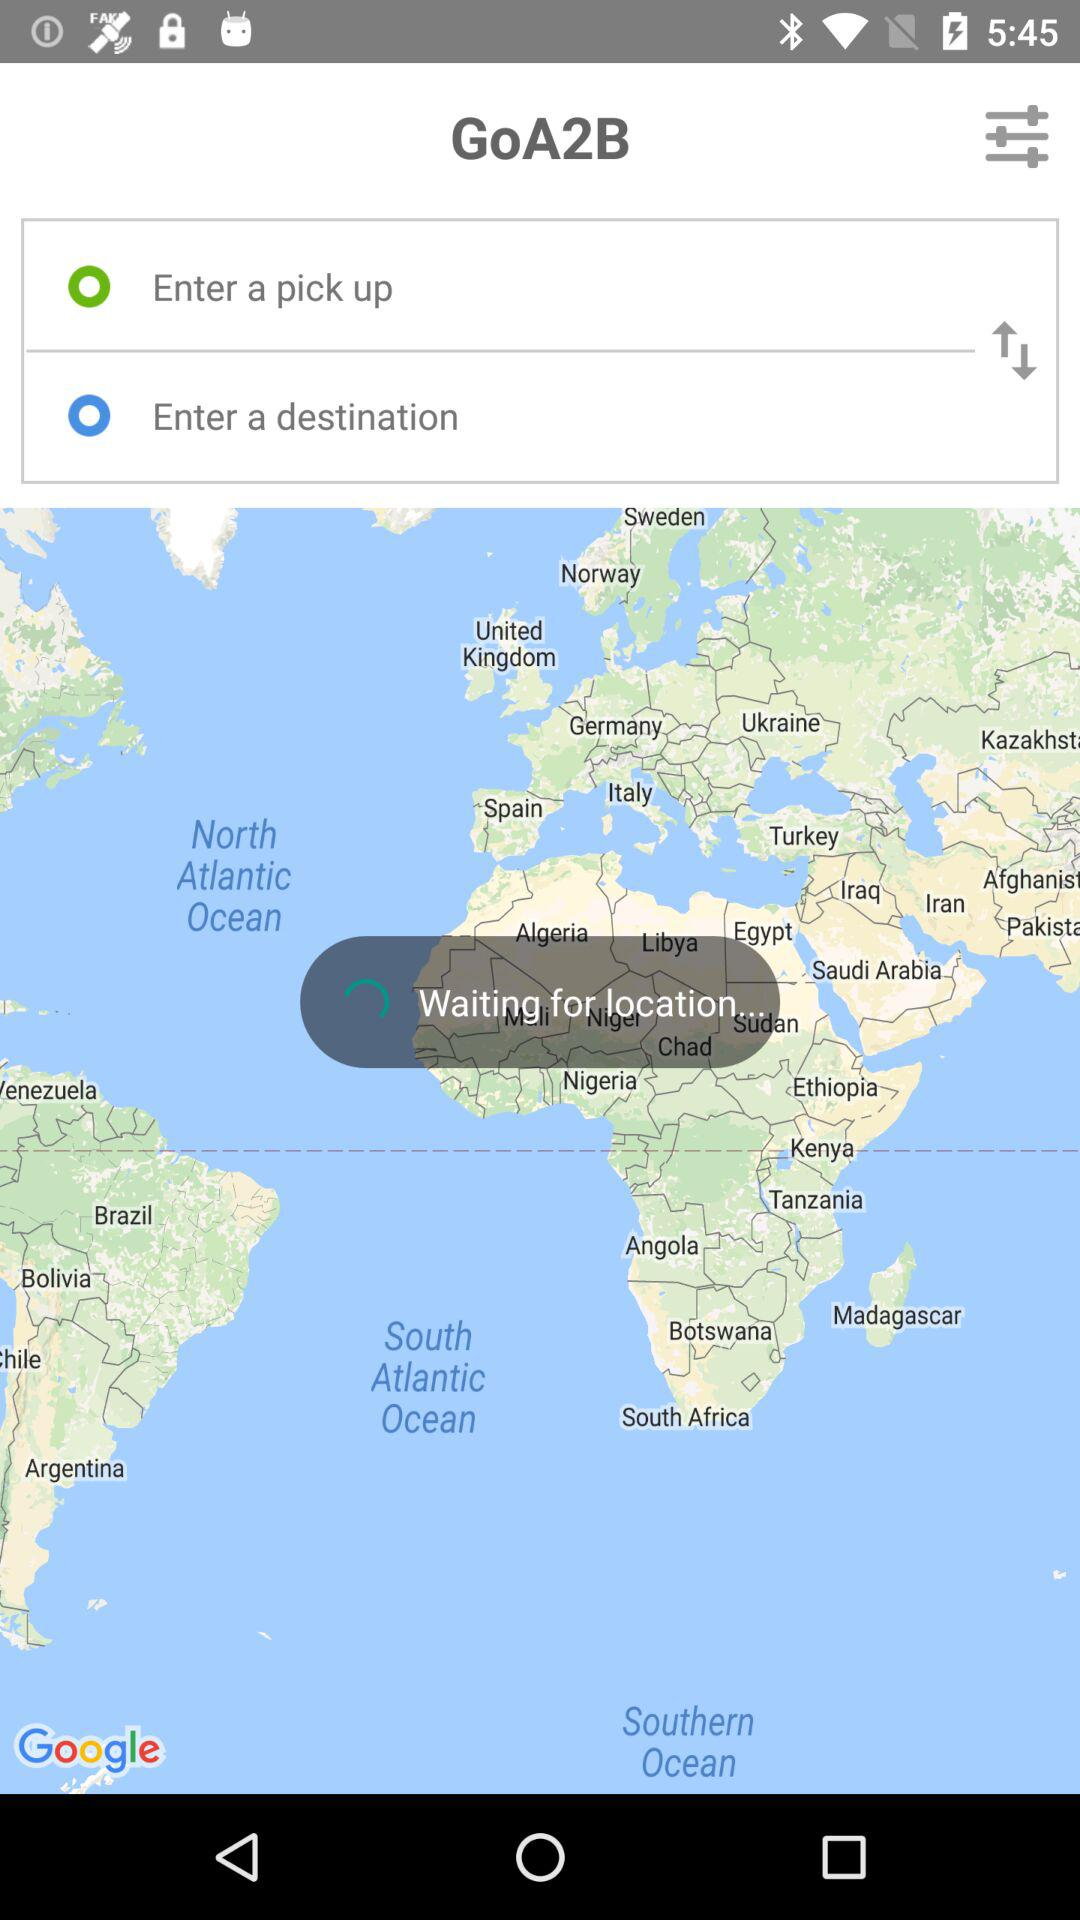What is the application name? The application name is "GoA2B". 